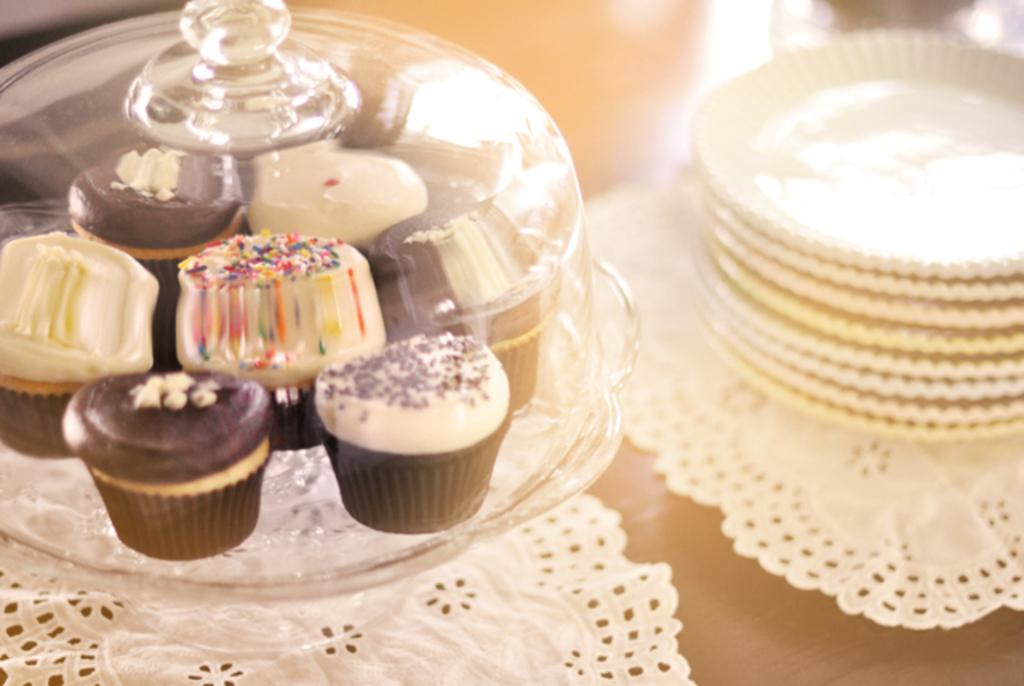What type of food is on the glass tray in the image? There are cupcakes on a glass tray in the image. What else can be seen in the image besides the cupcakes? There are plates in the image. What is the color of the table that the plates are on? The plates are on a brown table. What letter is written on the cupcakes in the image? There is no letter written on the cupcakes in the image. What type of love is depicted in the image? There is no depiction of love in the image; it features cupcakes on a glass tray and plates on a brown table. 